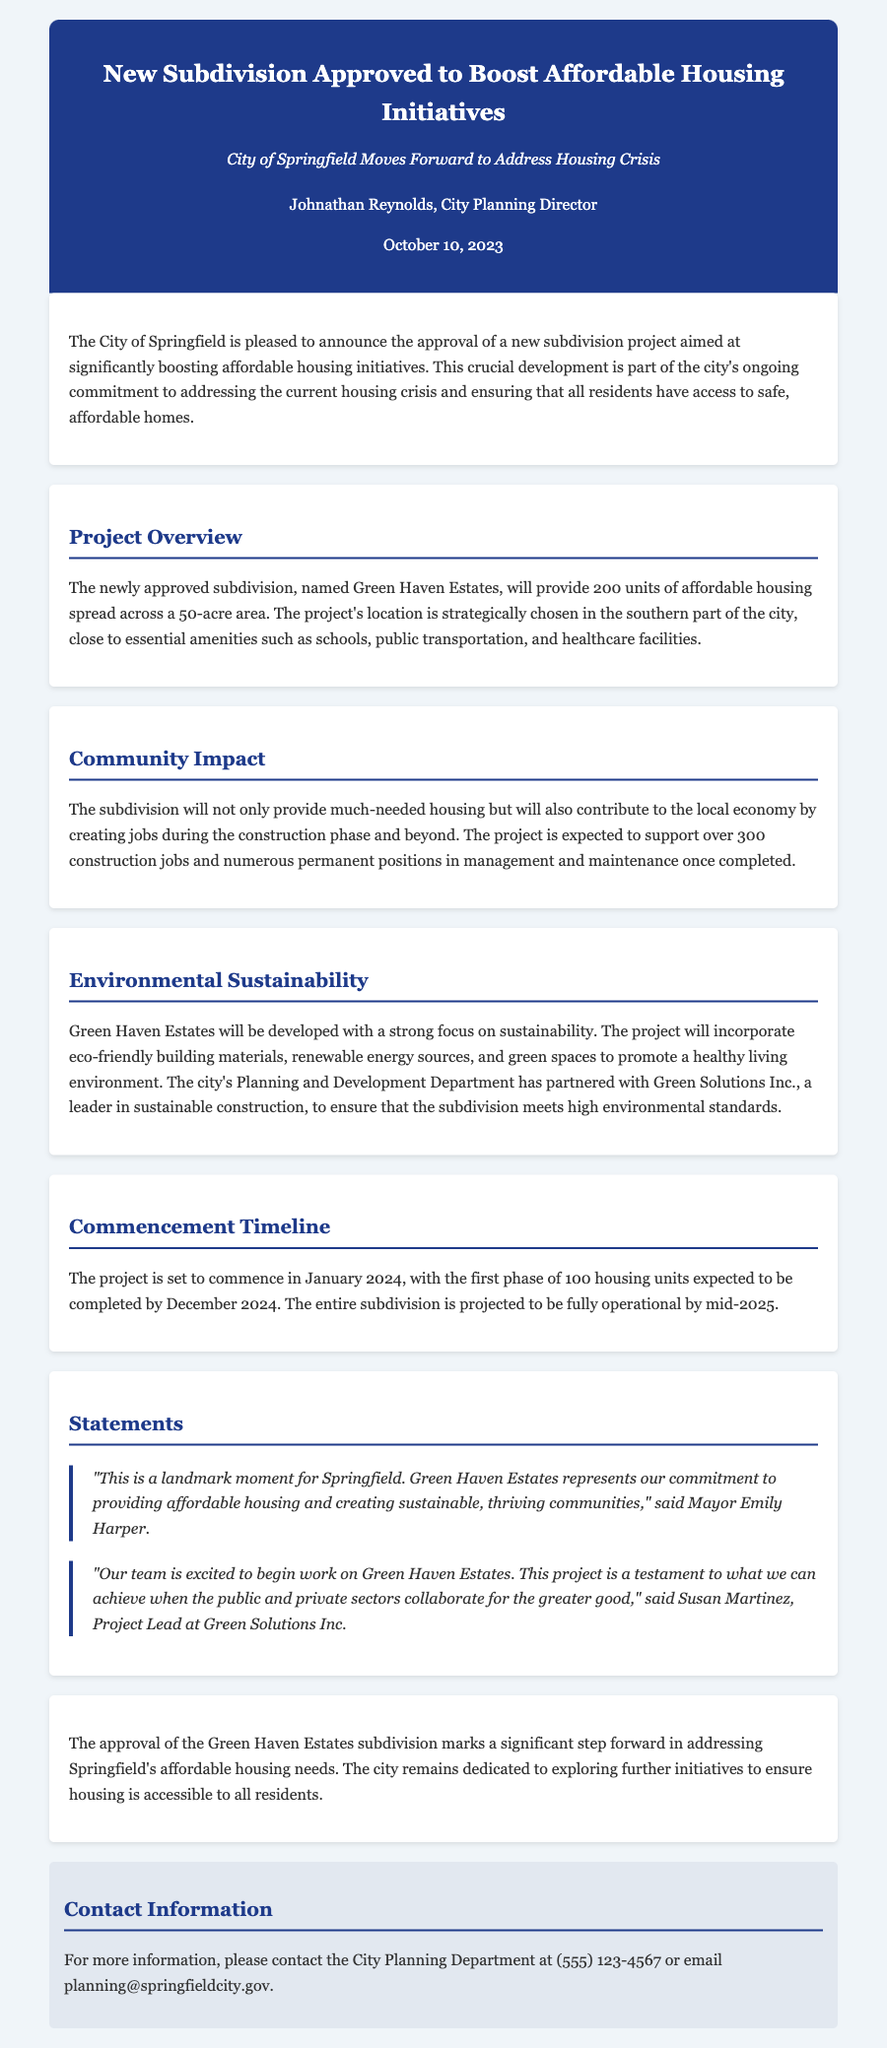What is the name of the new subdivision? The subdivision is named "Green Haven Estates."
Answer: Green Haven Estates How many units of affordable housing will be provided? The project will provide 200 units of affordable housing.
Answer: 200 units When is the project set to commence? The project is set to commence in January 2024.
Answer: January 2024 What is the expected completion date for the first phase of housing units? The first phase of 100 housing units is expected to be completed by December 2024.
Answer: December 2024 How many construction jobs is the project expected to support? The project is expected to support over 300 construction jobs.
Answer: Over 300 construction jobs Who is the Project Lead at Green Solutions Inc.? The Project Lead at Green Solutions Inc. is Susan Martinez.
Answer: Susan Martinez What will the project incorporate to promote a healthy living environment? The project will incorporate eco-friendly building materials, renewable energy sources, and green spaces.
Answer: Eco-friendly building materials, renewable energy sources, and green spaces What is the city's commitment as stated in the press release? The city's commitment is to providing affordable housing and creating sustainable, thriving communities.
Answer: Providing affordable housing and creating sustainable, thriving communities Which department partnered with Green Solutions Inc.? The city's Planning and Development Department partnered with Green Solutions Inc.
Answer: Planning and Development Department 